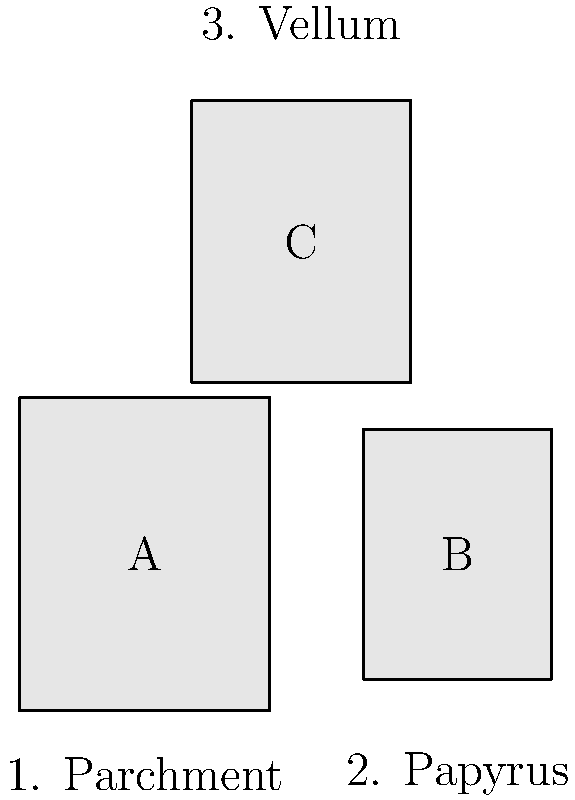As a local historian with expertise in educational history, you come across three scanned images of historical documents (labeled A, B, and C) from Merton Town's archives. Based on their visual characteristics, match each document to its likely material: parchment, papyrus, or vellum. Which document is most likely made of papyrus? To determine which document is most likely made of papyrus, let's analyze the characteristics of each material and compare them to the images:

1. Parchment:
   - Made from animal skin (usually sheep, goat, or calf)
   - Typically thick and sturdy
   - Often rectangular or square in shape
   - Can be quite large

2. Papyrus:
   - Made from the papyrus plant
   - Generally thinner and more fragile than parchment
   - Often has a more elongated, scroll-like appearance
   - Usually smaller in size due to manufacturing limitations

3. Vellum:
   - A high-quality form of parchment, typically made from calf skin
   - Very smooth and uniform in appearance
   - Often used for important documents or books
   - Can be various sizes, but often similar to parchment

Analyzing the images:

A: Large and rectangular, consistent with parchment characteristics
B: Smaller and more elongated, resembling papyrus
C: Medium-sized and very uniform in shape, suggesting vellum

Based on these observations, document B is the most likely candidate for papyrus due to its smaller size and elongated shape, which are typical characteristics of papyrus documents.
Answer: B 